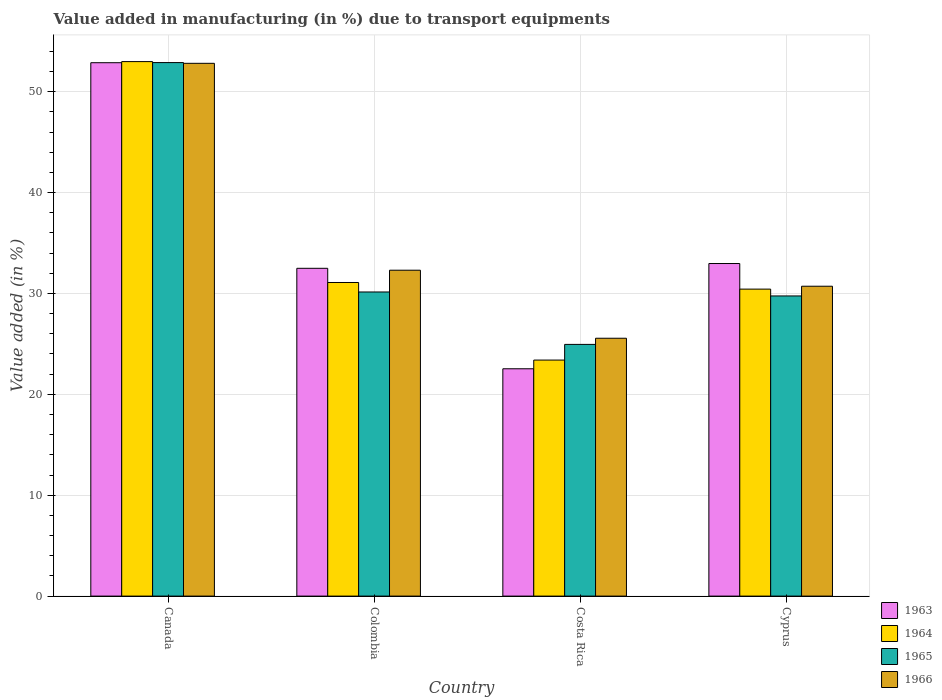How many different coloured bars are there?
Provide a succinct answer. 4. Are the number of bars on each tick of the X-axis equal?
Offer a very short reply. Yes. How many bars are there on the 1st tick from the left?
Your answer should be very brief. 4. How many bars are there on the 1st tick from the right?
Ensure brevity in your answer.  4. In how many cases, is the number of bars for a given country not equal to the number of legend labels?
Your response must be concise. 0. What is the percentage of value added in manufacturing due to transport equipments in 1965 in Costa Rica?
Keep it short and to the point. 24.95. Across all countries, what is the maximum percentage of value added in manufacturing due to transport equipments in 1963?
Make the answer very short. 52.87. Across all countries, what is the minimum percentage of value added in manufacturing due to transport equipments in 1965?
Your response must be concise. 24.95. What is the total percentage of value added in manufacturing due to transport equipments in 1964 in the graph?
Offer a terse response. 137.89. What is the difference between the percentage of value added in manufacturing due to transport equipments in 1963 in Canada and that in Colombia?
Offer a very short reply. 20.38. What is the difference between the percentage of value added in manufacturing due to transport equipments in 1966 in Cyprus and the percentage of value added in manufacturing due to transport equipments in 1965 in Canada?
Offer a very short reply. -22.17. What is the average percentage of value added in manufacturing due to transport equipments in 1966 per country?
Give a very brief answer. 35.35. What is the difference between the percentage of value added in manufacturing due to transport equipments of/in 1964 and percentage of value added in manufacturing due to transport equipments of/in 1965 in Colombia?
Your response must be concise. 0.94. In how many countries, is the percentage of value added in manufacturing due to transport equipments in 1963 greater than 48 %?
Your response must be concise. 1. What is the ratio of the percentage of value added in manufacturing due to transport equipments in 1964 in Colombia to that in Costa Rica?
Ensure brevity in your answer.  1.33. Is the difference between the percentage of value added in manufacturing due to transport equipments in 1964 in Canada and Cyprus greater than the difference between the percentage of value added in manufacturing due to transport equipments in 1965 in Canada and Cyprus?
Ensure brevity in your answer.  No. What is the difference between the highest and the second highest percentage of value added in manufacturing due to transport equipments in 1965?
Your answer should be very brief. 23.13. What is the difference between the highest and the lowest percentage of value added in manufacturing due to transport equipments in 1966?
Offer a very short reply. 27.25. In how many countries, is the percentage of value added in manufacturing due to transport equipments in 1966 greater than the average percentage of value added in manufacturing due to transport equipments in 1966 taken over all countries?
Offer a terse response. 1. Is the sum of the percentage of value added in manufacturing due to transport equipments in 1965 in Colombia and Cyprus greater than the maximum percentage of value added in manufacturing due to transport equipments in 1963 across all countries?
Provide a succinct answer. Yes. What does the 2nd bar from the left in Cyprus represents?
Your response must be concise. 1964. Is it the case that in every country, the sum of the percentage of value added in manufacturing due to transport equipments in 1963 and percentage of value added in manufacturing due to transport equipments in 1964 is greater than the percentage of value added in manufacturing due to transport equipments in 1965?
Make the answer very short. Yes. How many bars are there?
Your answer should be very brief. 16. How many countries are there in the graph?
Your answer should be very brief. 4. Are the values on the major ticks of Y-axis written in scientific E-notation?
Your answer should be compact. No. Does the graph contain any zero values?
Offer a very short reply. No. What is the title of the graph?
Provide a succinct answer. Value added in manufacturing (in %) due to transport equipments. What is the label or title of the Y-axis?
Offer a terse response. Value added (in %). What is the Value added (in %) in 1963 in Canada?
Keep it short and to the point. 52.87. What is the Value added (in %) of 1964 in Canada?
Your answer should be compact. 52.98. What is the Value added (in %) of 1965 in Canada?
Your answer should be very brief. 52.89. What is the Value added (in %) in 1966 in Canada?
Offer a very short reply. 52.81. What is the Value added (in %) in 1963 in Colombia?
Keep it short and to the point. 32.49. What is the Value added (in %) of 1964 in Colombia?
Offer a very short reply. 31.09. What is the Value added (in %) in 1965 in Colombia?
Keep it short and to the point. 30.15. What is the Value added (in %) in 1966 in Colombia?
Your answer should be compact. 32.3. What is the Value added (in %) in 1963 in Costa Rica?
Offer a very short reply. 22.53. What is the Value added (in %) in 1964 in Costa Rica?
Offer a very short reply. 23.4. What is the Value added (in %) of 1965 in Costa Rica?
Provide a succinct answer. 24.95. What is the Value added (in %) in 1966 in Costa Rica?
Give a very brief answer. 25.56. What is the Value added (in %) in 1963 in Cyprus?
Your response must be concise. 32.97. What is the Value added (in %) of 1964 in Cyprus?
Provide a short and direct response. 30.43. What is the Value added (in %) in 1965 in Cyprus?
Your answer should be compact. 29.75. What is the Value added (in %) in 1966 in Cyprus?
Give a very brief answer. 30.72. Across all countries, what is the maximum Value added (in %) of 1963?
Give a very brief answer. 52.87. Across all countries, what is the maximum Value added (in %) in 1964?
Provide a succinct answer. 52.98. Across all countries, what is the maximum Value added (in %) in 1965?
Offer a terse response. 52.89. Across all countries, what is the maximum Value added (in %) of 1966?
Provide a short and direct response. 52.81. Across all countries, what is the minimum Value added (in %) of 1963?
Give a very brief answer. 22.53. Across all countries, what is the minimum Value added (in %) in 1964?
Offer a terse response. 23.4. Across all countries, what is the minimum Value added (in %) in 1965?
Keep it short and to the point. 24.95. Across all countries, what is the minimum Value added (in %) of 1966?
Your answer should be compact. 25.56. What is the total Value added (in %) of 1963 in the graph?
Your response must be concise. 140.87. What is the total Value added (in %) in 1964 in the graph?
Provide a short and direct response. 137.89. What is the total Value added (in %) in 1965 in the graph?
Your answer should be very brief. 137.73. What is the total Value added (in %) in 1966 in the graph?
Your answer should be very brief. 141.39. What is the difference between the Value added (in %) of 1963 in Canada and that in Colombia?
Give a very brief answer. 20.38. What is the difference between the Value added (in %) of 1964 in Canada and that in Colombia?
Offer a terse response. 21.9. What is the difference between the Value added (in %) in 1965 in Canada and that in Colombia?
Ensure brevity in your answer.  22.74. What is the difference between the Value added (in %) of 1966 in Canada and that in Colombia?
Provide a short and direct response. 20.51. What is the difference between the Value added (in %) in 1963 in Canada and that in Costa Rica?
Make the answer very short. 30.34. What is the difference between the Value added (in %) of 1964 in Canada and that in Costa Rica?
Provide a succinct answer. 29.59. What is the difference between the Value added (in %) in 1965 in Canada and that in Costa Rica?
Make the answer very short. 27.93. What is the difference between the Value added (in %) of 1966 in Canada and that in Costa Rica?
Keep it short and to the point. 27.25. What is the difference between the Value added (in %) of 1963 in Canada and that in Cyprus?
Give a very brief answer. 19.91. What is the difference between the Value added (in %) of 1964 in Canada and that in Cyprus?
Keep it short and to the point. 22.55. What is the difference between the Value added (in %) of 1965 in Canada and that in Cyprus?
Ensure brevity in your answer.  23.13. What is the difference between the Value added (in %) of 1966 in Canada and that in Cyprus?
Provide a short and direct response. 22.1. What is the difference between the Value added (in %) in 1963 in Colombia and that in Costa Rica?
Keep it short and to the point. 9.96. What is the difference between the Value added (in %) of 1964 in Colombia and that in Costa Rica?
Provide a short and direct response. 7.69. What is the difference between the Value added (in %) in 1965 in Colombia and that in Costa Rica?
Keep it short and to the point. 5.2. What is the difference between the Value added (in %) in 1966 in Colombia and that in Costa Rica?
Offer a terse response. 6.74. What is the difference between the Value added (in %) of 1963 in Colombia and that in Cyprus?
Offer a very short reply. -0.47. What is the difference between the Value added (in %) in 1964 in Colombia and that in Cyprus?
Provide a succinct answer. 0.66. What is the difference between the Value added (in %) in 1965 in Colombia and that in Cyprus?
Provide a short and direct response. 0.39. What is the difference between the Value added (in %) of 1966 in Colombia and that in Cyprus?
Your response must be concise. 1.59. What is the difference between the Value added (in %) in 1963 in Costa Rica and that in Cyprus?
Provide a short and direct response. -10.43. What is the difference between the Value added (in %) in 1964 in Costa Rica and that in Cyprus?
Your answer should be compact. -7.03. What is the difference between the Value added (in %) of 1965 in Costa Rica and that in Cyprus?
Your answer should be compact. -4.8. What is the difference between the Value added (in %) in 1966 in Costa Rica and that in Cyprus?
Ensure brevity in your answer.  -5.16. What is the difference between the Value added (in %) in 1963 in Canada and the Value added (in %) in 1964 in Colombia?
Make the answer very short. 21.79. What is the difference between the Value added (in %) in 1963 in Canada and the Value added (in %) in 1965 in Colombia?
Ensure brevity in your answer.  22.73. What is the difference between the Value added (in %) in 1963 in Canada and the Value added (in %) in 1966 in Colombia?
Give a very brief answer. 20.57. What is the difference between the Value added (in %) of 1964 in Canada and the Value added (in %) of 1965 in Colombia?
Your answer should be very brief. 22.84. What is the difference between the Value added (in %) in 1964 in Canada and the Value added (in %) in 1966 in Colombia?
Ensure brevity in your answer.  20.68. What is the difference between the Value added (in %) in 1965 in Canada and the Value added (in %) in 1966 in Colombia?
Provide a succinct answer. 20.58. What is the difference between the Value added (in %) in 1963 in Canada and the Value added (in %) in 1964 in Costa Rica?
Offer a very short reply. 29.48. What is the difference between the Value added (in %) of 1963 in Canada and the Value added (in %) of 1965 in Costa Rica?
Your answer should be very brief. 27.92. What is the difference between the Value added (in %) in 1963 in Canada and the Value added (in %) in 1966 in Costa Rica?
Ensure brevity in your answer.  27.31. What is the difference between the Value added (in %) in 1964 in Canada and the Value added (in %) in 1965 in Costa Rica?
Offer a very short reply. 28.03. What is the difference between the Value added (in %) in 1964 in Canada and the Value added (in %) in 1966 in Costa Rica?
Give a very brief answer. 27.42. What is the difference between the Value added (in %) of 1965 in Canada and the Value added (in %) of 1966 in Costa Rica?
Make the answer very short. 27.33. What is the difference between the Value added (in %) in 1963 in Canada and the Value added (in %) in 1964 in Cyprus?
Make the answer very short. 22.44. What is the difference between the Value added (in %) of 1963 in Canada and the Value added (in %) of 1965 in Cyprus?
Ensure brevity in your answer.  23.12. What is the difference between the Value added (in %) in 1963 in Canada and the Value added (in %) in 1966 in Cyprus?
Your response must be concise. 22.16. What is the difference between the Value added (in %) of 1964 in Canada and the Value added (in %) of 1965 in Cyprus?
Keep it short and to the point. 23.23. What is the difference between the Value added (in %) in 1964 in Canada and the Value added (in %) in 1966 in Cyprus?
Ensure brevity in your answer.  22.27. What is the difference between the Value added (in %) in 1965 in Canada and the Value added (in %) in 1966 in Cyprus?
Offer a very short reply. 22.17. What is the difference between the Value added (in %) of 1963 in Colombia and the Value added (in %) of 1964 in Costa Rica?
Give a very brief answer. 9.1. What is the difference between the Value added (in %) in 1963 in Colombia and the Value added (in %) in 1965 in Costa Rica?
Keep it short and to the point. 7.54. What is the difference between the Value added (in %) of 1963 in Colombia and the Value added (in %) of 1966 in Costa Rica?
Offer a terse response. 6.93. What is the difference between the Value added (in %) of 1964 in Colombia and the Value added (in %) of 1965 in Costa Rica?
Provide a succinct answer. 6.14. What is the difference between the Value added (in %) in 1964 in Colombia and the Value added (in %) in 1966 in Costa Rica?
Offer a terse response. 5.53. What is the difference between the Value added (in %) in 1965 in Colombia and the Value added (in %) in 1966 in Costa Rica?
Provide a short and direct response. 4.59. What is the difference between the Value added (in %) of 1963 in Colombia and the Value added (in %) of 1964 in Cyprus?
Your answer should be compact. 2.06. What is the difference between the Value added (in %) of 1963 in Colombia and the Value added (in %) of 1965 in Cyprus?
Keep it short and to the point. 2.74. What is the difference between the Value added (in %) of 1963 in Colombia and the Value added (in %) of 1966 in Cyprus?
Provide a succinct answer. 1.78. What is the difference between the Value added (in %) of 1964 in Colombia and the Value added (in %) of 1965 in Cyprus?
Make the answer very short. 1.33. What is the difference between the Value added (in %) in 1964 in Colombia and the Value added (in %) in 1966 in Cyprus?
Offer a terse response. 0.37. What is the difference between the Value added (in %) in 1965 in Colombia and the Value added (in %) in 1966 in Cyprus?
Your answer should be very brief. -0.57. What is the difference between the Value added (in %) in 1963 in Costa Rica and the Value added (in %) in 1964 in Cyprus?
Make the answer very short. -7.9. What is the difference between the Value added (in %) in 1963 in Costa Rica and the Value added (in %) in 1965 in Cyprus?
Provide a succinct answer. -7.22. What is the difference between the Value added (in %) of 1963 in Costa Rica and the Value added (in %) of 1966 in Cyprus?
Your answer should be compact. -8.18. What is the difference between the Value added (in %) in 1964 in Costa Rica and the Value added (in %) in 1965 in Cyprus?
Make the answer very short. -6.36. What is the difference between the Value added (in %) of 1964 in Costa Rica and the Value added (in %) of 1966 in Cyprus?
Make the answer very short. -7.32. What is the difference between the Value added (in %) in 1965 in Costa Rica and the Value added (in %) in 1966 in Cyprus?
Offer a very short reply. -5.77. What is the average Value added (in %) of 1963 per country?
Provide a succinct answer. 35.22. What is the average Value added (in %) of 1964 per country?
Your answer should be very brief. 34.47. What is the average Value added (in %) in 1965 per country?
Give a very brief answer. 34.43. What is the average Value added (in %) of 1966 per country?
Give a very brief answer. 35.35. What is the difference between the Value added (in %) in 1963 and Value added (in %) in 1964 in Canada?
Ensure brevity in your answer.  -0.11. What is the difference between the Value added (in %) of 1963 and Value added (in %) of 1965 in Canada?
Your answer should be compact. -0.01. What is the difference between the Value added (in %) of 1963 and Value added (in %) of 1966 in Canada?
Your answer should be very brief. 0.06. What is the difference between the Value added (in %) of 1964 and Value added (in %) of 1965 in Canada?
Give a very brief answer. 0.1. What is the difference between the Value added (in %) in 1964 and Value added (in %) in 1966 in Canada?
Your answer should be compact. 0.17. What is the difference between the Value added (in %) of 1965 and Value added (in %) of 1966 in Canada?
Your answer should be compact. 0.07. What is the difference between the Value added (in %) in 1963 and Value added (in %) in 1964 in Colombia?
Your answer should be very brief. 1.41. What is the difference between the Value added (in %) of 1963 and Value added (in %) of 1965 in Colombia?
Your response must be concise. 2.35. What is the difference between the Value added (in %) in 1963 and Value added (in %) in 1966 in Colombia?
Your response must be concise. 0.19. What is the difference between the Value added (in %) in 1964 and Value added (in %) in 1965 in Colombia?
Provide a succinct answer. 0.94. What is the difference between the Value added (in %) of 1964 and Value added (in %) of 1966 in Colombia?
Offer a very short reply. -1.22. What is the difference between the Value added (in %) in 1965 and Value added (in %) in 1966 in Colombia?
Offer a very short reply. -2.16. What is the difference between the Value added (in %) in 1963 and Value added (in %) in 1964 in Costa Rica?
Your response must be concise. -0.86. What is the difference between the Value added (in %) of 1963 and Value added (in %) of 1965 in Costa Rica?
Offer a very short reply. -2.42. What is the difference between the Value added (in %) in 1963 and Value added (in %) in 1966 in Costa Rica?
Offer a terse response. -3.03. What is the difference between the Value added (in %) in 1964 and Value added (in %) in 1965 in Costa Rica?
Provide a succinct answer. -1.55. What is the difference between the Value added (in %) of 1964 and Value added (in %) of 1966 in Costa Rica?
Offer a very short reply. -2.16. What is the difference between the Value added (in %) in 1965 and Value added (in %) in 1966 in Costa Rica?
Keep it short and to the point. -0.61. What is the difference between the Value added (in %) in 1963 and Value added (in %) in 1964 in Cyprus?
Give a very brief answer. 2.54. What is the difference between the Value added (in %) of 1963 and Value added (in %) of 1965 in Cyprus?
Keep it short and to the point. 3.21. What is the difference between the Value added (in %) of 1963 and Value added (in %) of 1966 in Cyprus?
Your response must be concise. 2.25. What is the difference between the Value added (in %) of 1964 and Value added (in %) of 1965 in Cyprus?
Ensure brevity in your answer.  0.68. What is the difference between the Value added (in %) of 1964 and Value added (in %) of 1966 in Cyprus?
Your answer should be very brief. -0.29. What is the difference between the Value added (in %) in 1965 and Value added (in %) in 1966 in Cyprus?
Offer a very short reply. -0.96. What is the ratio of the Value added (in %) of 1963 in Canada to that in Colombia?
Offer a terse response. 1.63. What is the ratio of the Value added (in %) of 1964 in Canada to that in Colombia?
Your answer should be compact. 1.7. What is the ratio of the Value added (in %) in 1965 in Canada to that in Colombia?
Offer a terse response. 1.75. What is the ratio of the Value added (in %) in 1966 in Canada to that in Colombia?
Offer a terse response. 1.63. What is the ratio of the Value added (in %) in 1963 in Canada to that in Costa Rica?
Keep it short and to the point. 2.35. What is the ratio of the Value added (in %) of 1964 in Canada to that in Costa Rica?
Make the answer very short. 2.26. What is the ratio of the Value added (in %) in 1965 in Canada to that in Costa Rica?
Provide a short and direct response. 2.12. What is the ratio of the Value added (in %) of 1966 in Canada to that in Costa Rica?
Your response must be concise. 2.07. What is the ratio of the Value added (in %) of 1963 in Canada to that in Cyprus?
Give a very brief answer. 1.6. What is the ratio of the Value added (in %) of 1964 in Canada to that in Cyprus?
Keep it short and to the point. 1.74. What is the ratio of the Value added (in %) in 1965 in Canada to that in Cyprus?
Offer a terse response. 1.78. What is the ratio of the Value added (in %) of 1966 in Canada to that in Cyprus?
Keep it short and to the point. 1.72. What is the ratio of the Value added (in %) of 1963 in Colombia to that in Costa Rica?
Your answer should be compact. 1.44. What is the ratio of the Value added (in %) of 1964 in Colombia to that in Costa Rica?
Your answer should be compact. 1.33. What is the ratio of the Value added (in %) of 1965 in Colombia to that in Costa Rica?
Offer a very short reply. 1.21. What is the ratio of the Value added (in %) of 1966 in Colombia to that in Costa Rica?
Give a very brief answer. 1.26. What is the ratio of the Value added (in %) in 1963 in Colombia to that in Cyprus?
Provide a short and direct response. 0.99. What is the ratio of the Value added (in %) in 1964 in Colombia to that in Cyprus?
Keep it short and to the point. 1.02. What is the ratio of the Value added (in %) in 1965 in Colombia to that in Cyprus?
Offer a very short reply. 1.01. What is the ratio of the Value added (in %) of 1966 in Colombia to that in Cyprus?
Make the answer very short. 1.05. What is the ratio of the Value added (in %) in 1963 in Costa Rica to that in Cyprus?
Give a very brief answer. 0.68. What is the ratio of the Value added (in %) in 1964 in Costa Rica to that in Cyprus?
Provide a short and direct response. 0.77. What is the ratio of the Value added (in %) of 1965 in Costa Rica to that in Cyprus?
Your answer should be very brief. 0.84. What is the ratio of the Value added (in %) in 1966 in Costa Rica to that in Cyprus?
Provide a short and direct response. 0.83. What is the difference between the highest and the second highest Value added (in %) of 1963?
Provide a succinct answer. 19.91. What is the difference between the highest and the second highest Value added (in %) of 1964?
Provide a succinct answer. 21.9. What is the difference between the highest and the second highest Value added (in %) in 1965?
Your answer should be compact. 22.74. What is the difference between the highest and the second highest Value added (in %) in 1966?
Keep it short and to the point. 20.51. What is the difference between the highest and the lowest Value added (in %) in 1963?
Provide a succinct answer. 30.34. What is the difference between the highest and the lowest Value added (in %) in 1964?
Your response must be concise. 29.59. What is the difference between the highest and the lowest Value added (in %) of 1965?
Provide a short and direct response. 27.93. What is the difference between the highest and the lowest Value added (in %) in 1966?
Give a very brief answer. 27.25. 